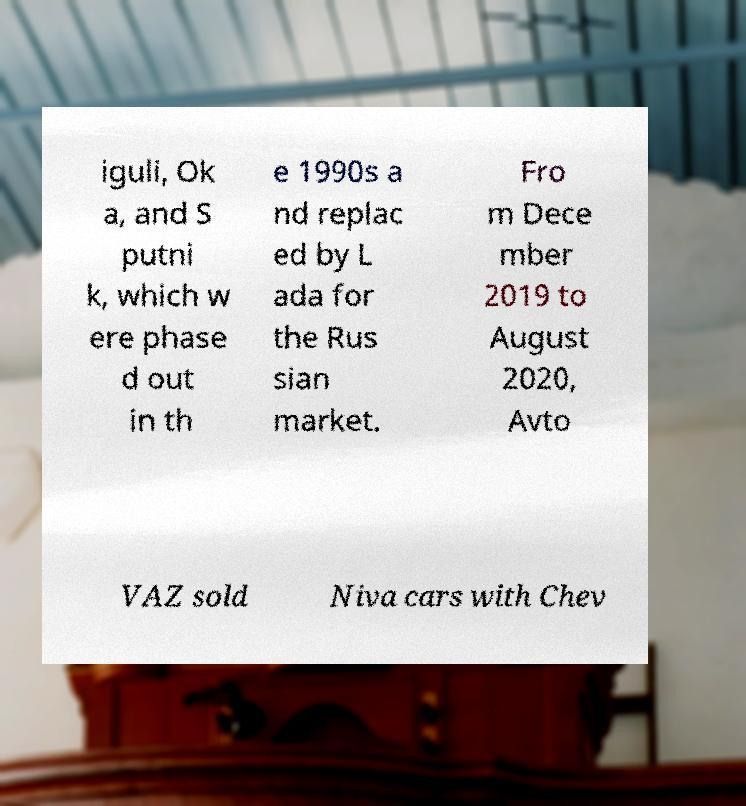What messages or text are displayed in this image? I need them in a readable, typed format. iguli, Ok a, and S putni k, which w ere phase d out in th e 1990s a nd replac ed by L ada for the Rus sian market. Fro m Dece mber 2019 to August 2020, Avto VAZ sold Niva cars with Chev 